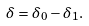<formula> <loc_0><loc_0><loc_500><loc_500>\delta = \delta _ { 0 } - \delta _ { 1 } .</formula> 